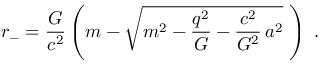Convert formula to latex. <formula><loc_0><loc_0><loc_500><loc_500>r _ { - } = \frac { G } { c ^ { 2 } } \left ( m - \sqrt { m ^ { 2 } - \frac { q ^ { 2 } } { G } - \frac { c ^ { 2 } } { G ^ { 2 } } \, a ^ { 2 } } \, \right ) \, .</formula> 